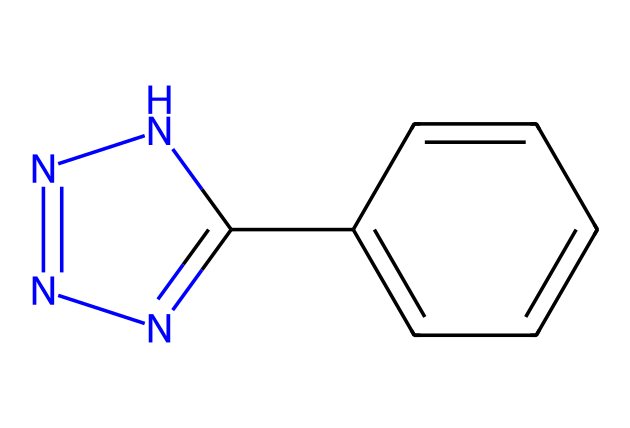What is the molecular formula of this compound? The given SMILES represents a chemical structure with the following atoms: 8 carbon (C) atoms, 10 hydrogen (H) atoms, and 4 nitrogen (N) atoms. Therefore, the molecular formula is calculated by counting these atoms.
Answer: C8H10N4 How many rings are present in this structure? The SMILES indicates the presence of two cyclic components. The 'C1' and 'C2' notations signify the start of rings, and the corresponding closing 'C1' and 'C2' indicate the closure of those rings. Therefore, there are two rings present in this structure.
Answer: 2 What type of functional groups are indicated in this compound? The presence of nitrogen atoms connected within a ring suggests the presence of hydrazine groups. Additionally, the presence of aromatic rings suggests the compound is aromatic, which are considered functional groups in organic chemistry.
Answer: hydrazine and aromatic What is the total number of nitrogen atoms in this structure? By examining the SMILES representation, there are four nitrogen (N) atoms present in the formula. Each nitrogen atom is denoted in the structure, and counting them confirms their total.
Answer: 4 Which part of this chemical contributes to its potential biological activity? The nitrogen atoms and their arrangement within the rings suggest potential interactions with biological targets such as enzymes or receptors. Nitrogen is often a key site in drug interactions, particularly in heterocycles.
Answer: nitrogen atoms What type of drug class might this compound belong to? Given the structural features of this compound, particularly the presence of nitrogen and aromatic rings, it is likely to fall into the class of anti-cancer or anti-viral drugs, which often contain similar structures due to their biological activity.
Answer: anti-cancer or anti-viral 